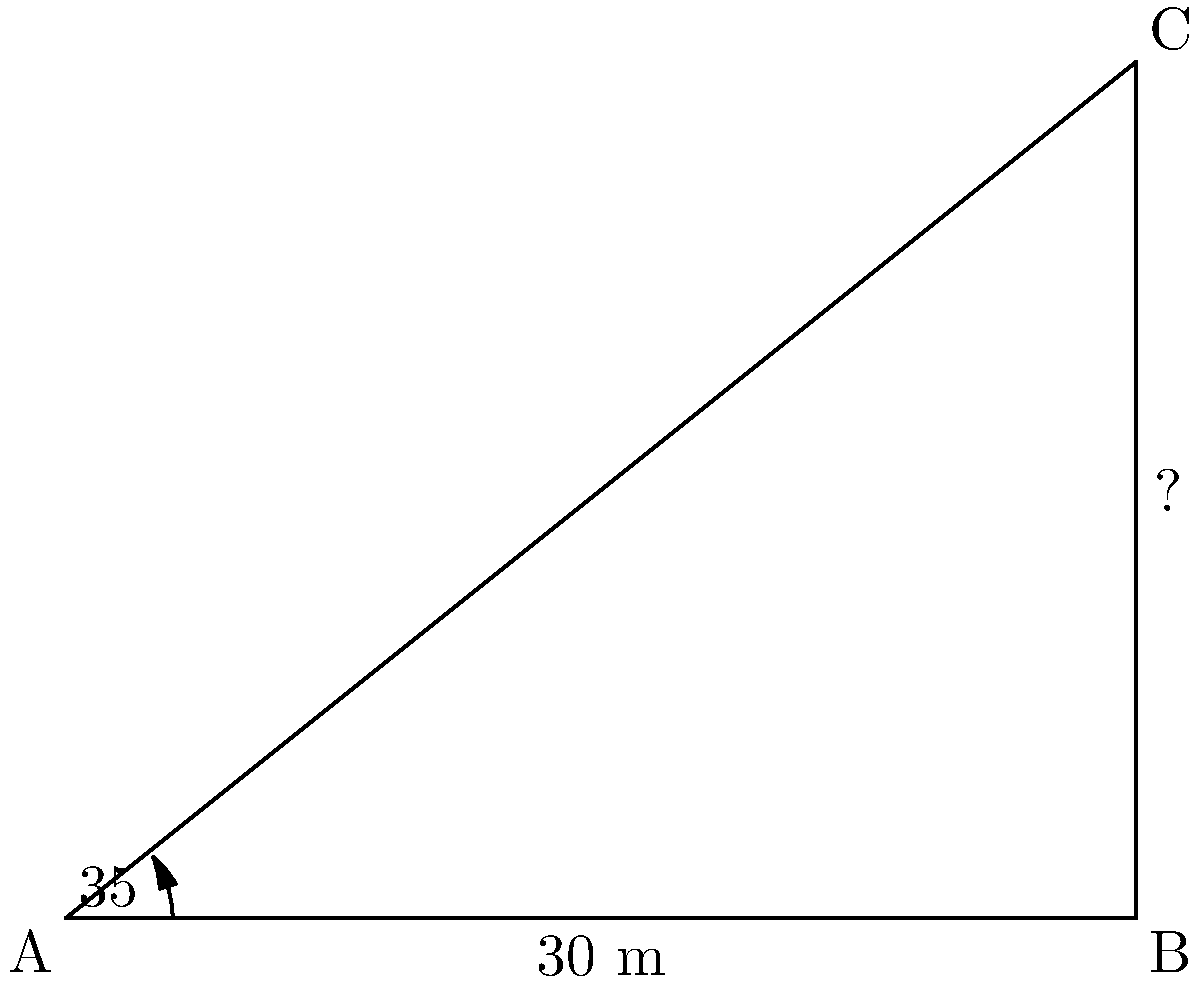From the base of the Cebu Metropolitan Cathedral, you spot a tourist standing 30 meters away, looking up at the top of the cathedral's bell tower. If the angle of elevation from the tourist's position to the top of the bell tower is 35°, what is the height of the bell tower? Let's approach this step-by-step:

1) We can model this situation as a right-angled triangle, where:
   - The base of the triangle is the distance from the tourist to the cathedral (30 m)
   - The height of the triangle is the height of the bell tower
   - The angle at the base is the angle of elevation (35°)

2) In this right-angled triangle, we know:
   - The adjacent side (base) = 30 m
   - The angle = 35°
   - We need to find the opposite side (height)

3) This is a perfect scenario to use the tangent trigonometric function:

   $\tan(\theta) = \frac{\text{opposite}}{\text{adjacent}}$

4) Substituting our known values:

   $\tan(35°) = \frac{\text{height}}{30}$

5) To solve for the height, we multiply both sides by 30:

   $30 \times \tan(35°) = \text{height}$

6) Now we can calculate:
   
   $\text{height} = 30 \times \tan(35°) \approx 21.00 \text{ m}$

7) Rounding to two decimal places, the height of the bell tower is approximately 21.00 meters.
Answer: 21.00 m 